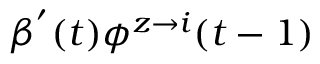Convert formula to latex. <formula><loc_0><loc_0><loc_500><loc_500>\beta ^ { ^ { \prime } } ( t ) \phi ^ { z \rightarrow i } ( t - 1 )</formula> 